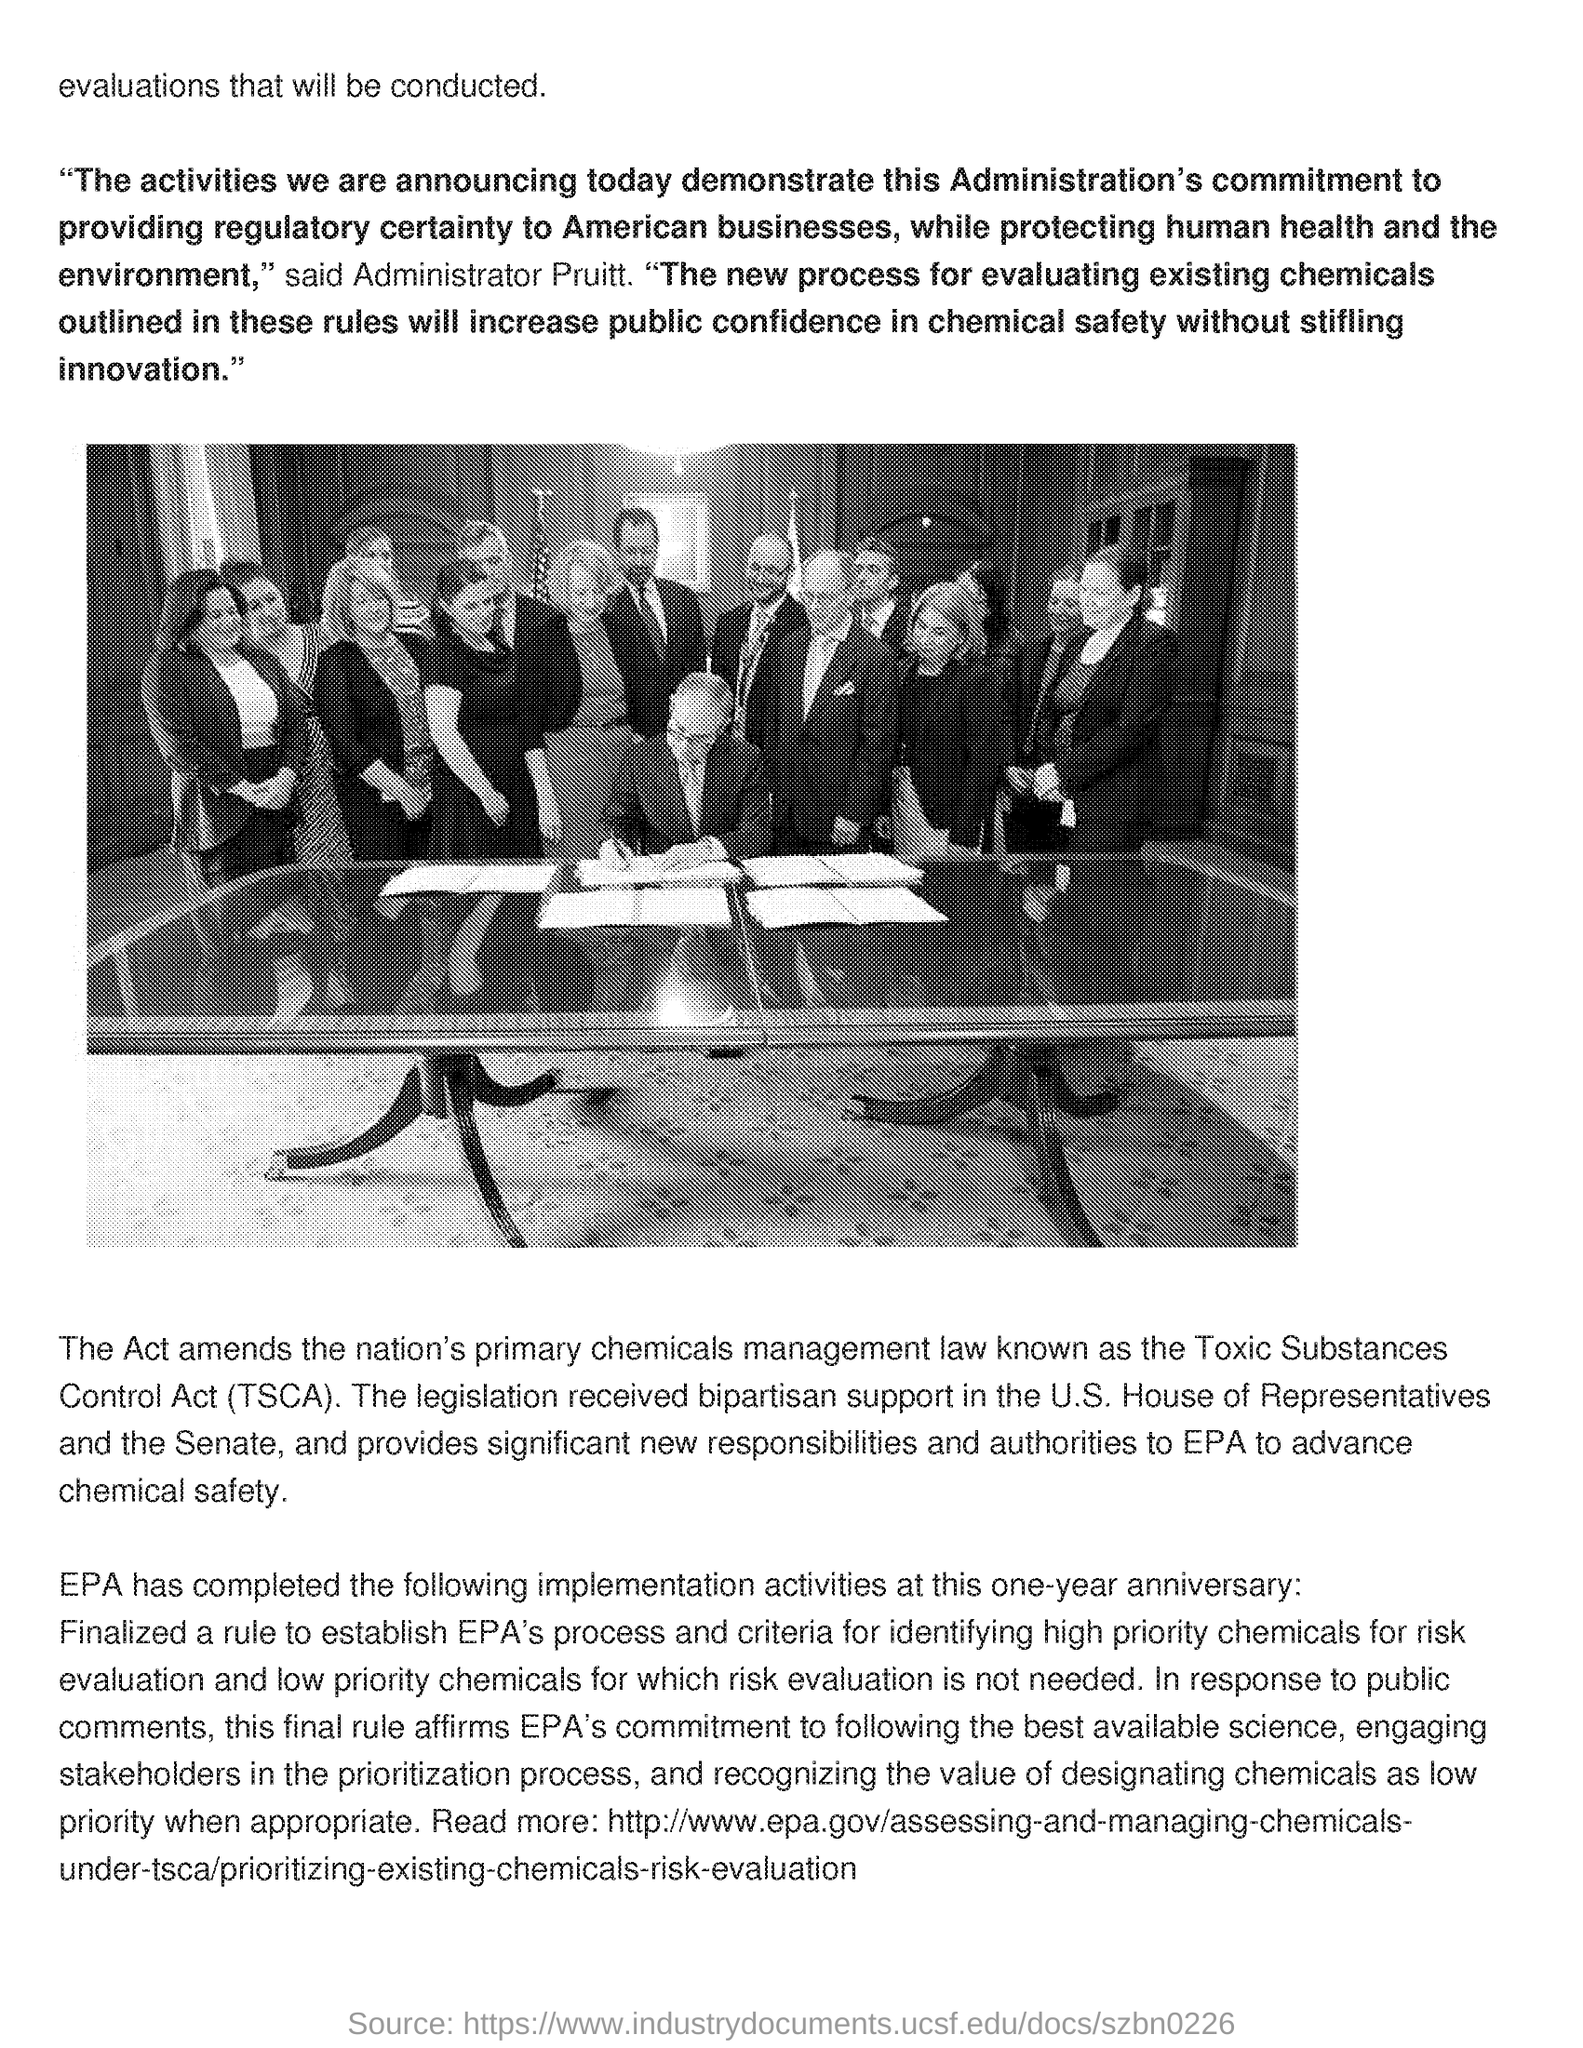What is the full form of TSCA?
Provide a succinct answer. Toxic Substances Control Act. 